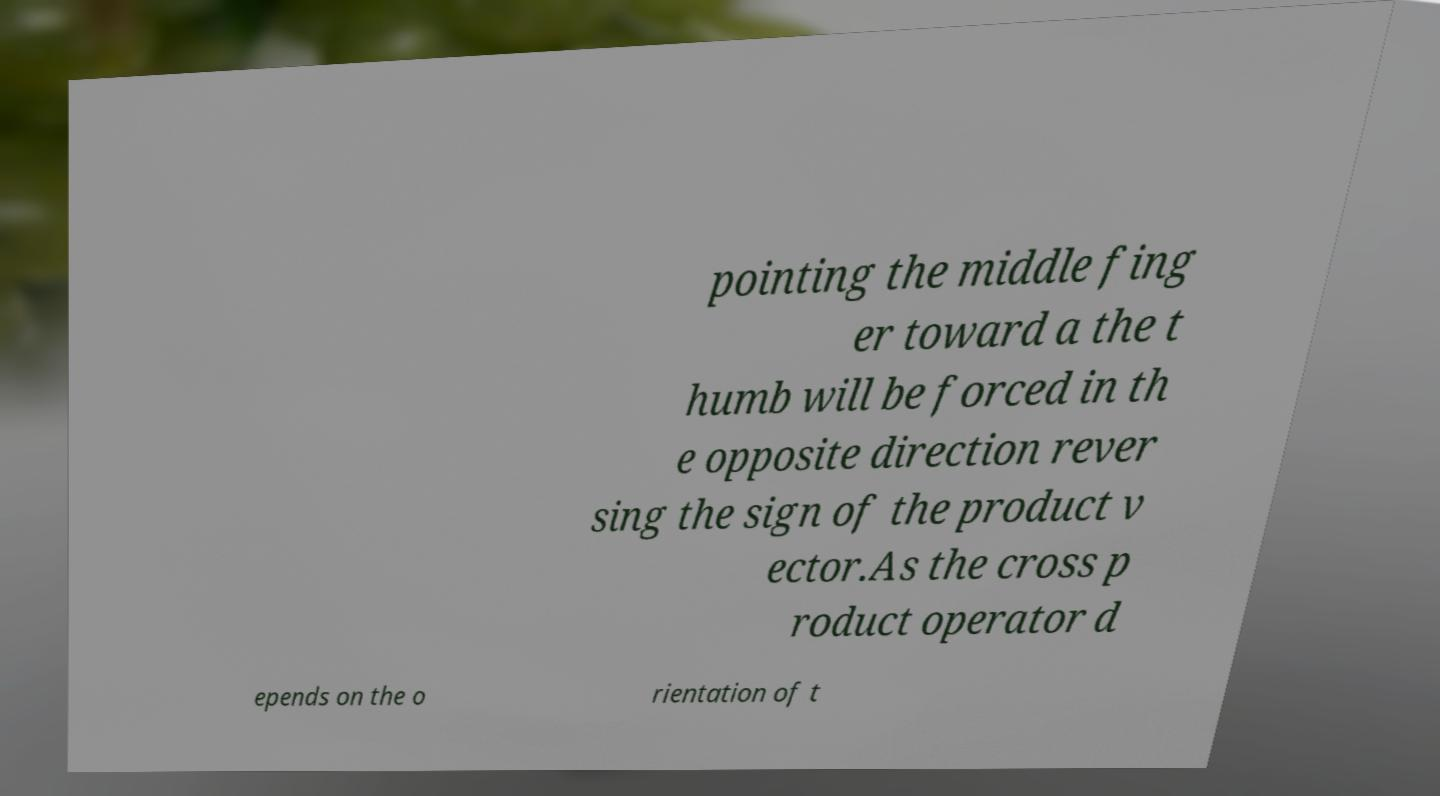Please read and relay the text visible in this image. What does it say? pointing the middle fing er toward a the t humb will be forced in th e opposite direction rever sing the sign of the product v ector.As the cross p roduct operator d epends on the o rientation of t 